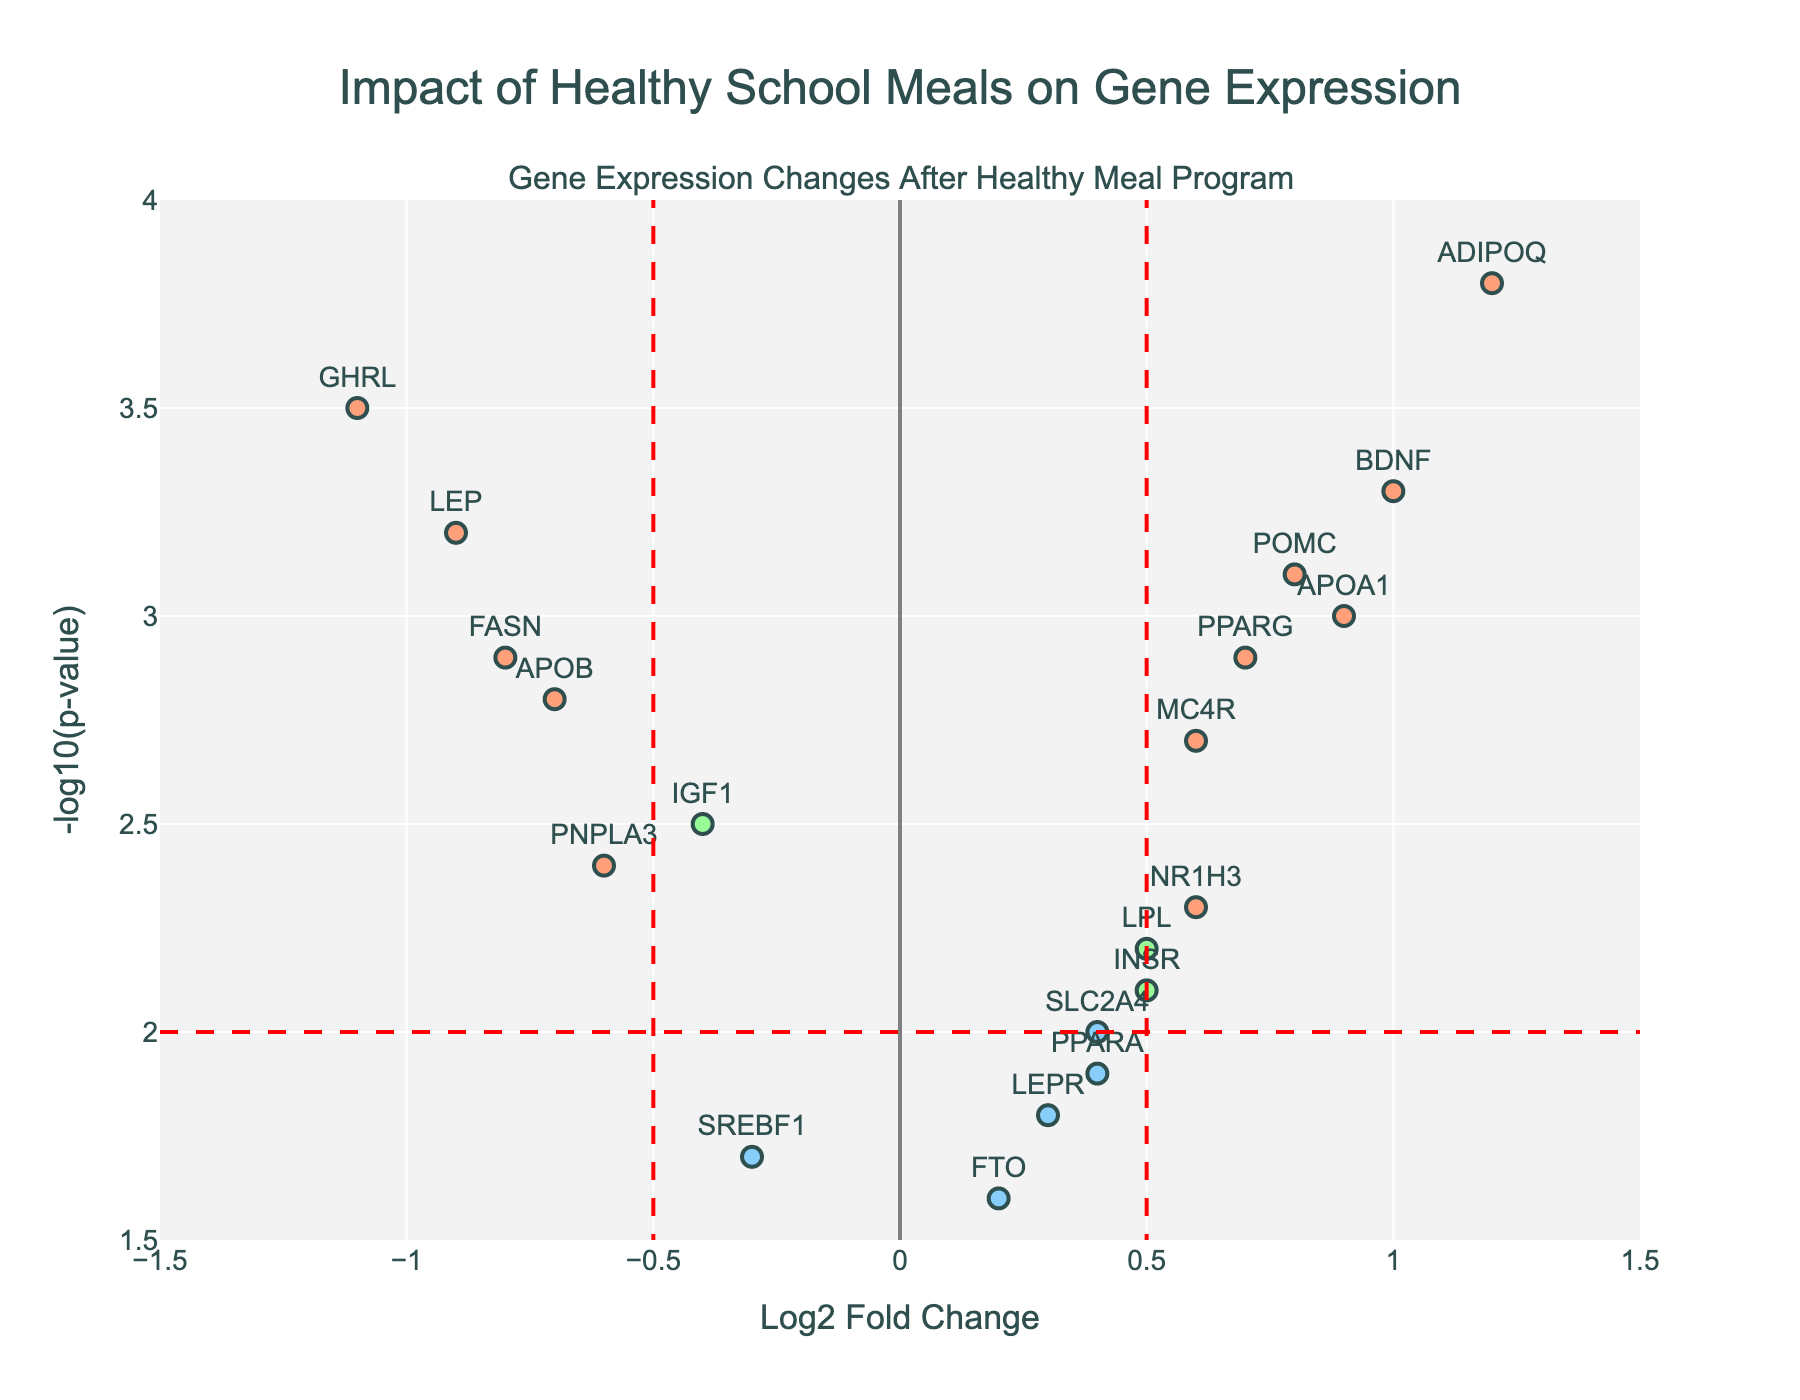How many genes are depicted in the plot? Count the number of data points displayed in the plot. Each point represents a gene.
Answer: 19 What is the title of the figure? Look at the text displayed at the top of the figure.
Answer: Impact of Healthy School Meals on Gene Expression Which gene has the highest Log2 Fold Change? Identify the gene with the highest value on the x-axis.
Answer: ADIPOQ How many genes have a Log2 Fold Change greater than 0.5? Count the number of data points with x-values greater than 0.5.
Answer: 5 Which gene has the highest -log10(p-value)? Identify the gene with the highest value on the y-axis.
Answer: ADIPOQ How many genes meet both the Log2 Fold Change and p-value thresholds? Count the number of data points with absolute Log2 Fold Change > 0.5 and -log10(p-value) > 2.
Answer: 6 Which genes have a Log2 Fold Change less than -0.5 and a -log10(p-value) greater than 2? Identify the data points situated in the lower left sector created by Log2 Fold Change < -0.5 and -log10(p-value) > 2.
Answer: LEP, GHRL, PNPLA3, APOB Which genes are above the p-value threshold but have a Log2 Fold Change within -0.5 to 0.5? Identify the data points above the red horizontal threshold line, but within the region between -0.5 and 0.5 on the x-axis.
Answer: INSR, LEPR, IGF1, SLC2A4, NR1H3, PPARA What is the average -log10(p-value) for genes with a positive Log2 Fold Change greater than 0.5? Sum the -log10(p-values) for genes with a Log2 Fold Change > 0.5 and divide by the count of these genes.
Answer: (3.8 + 2.9 + 2.7 + 3.1 + 3.3 + 3.0) / 6 = 2.97 